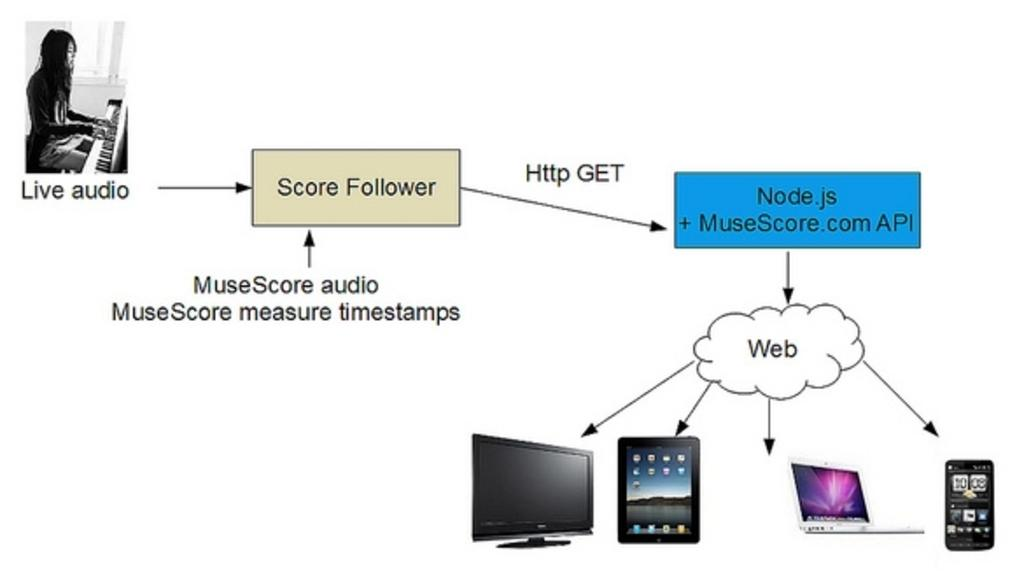<image>
Share a concise interpretation of the image provided. A diagram has a picture of a woman playing piano with the words live audio below. 